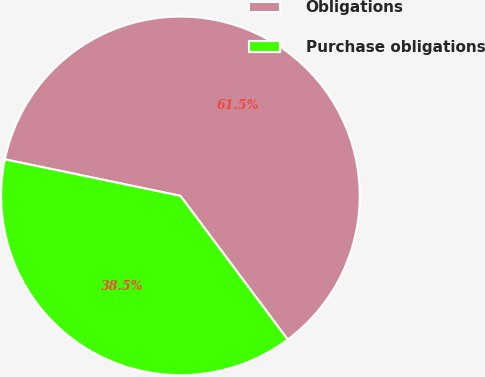Convert chart. <chart><loc_0><loc_0><loc_500><loc_500><pie_chart><fcel>Obligations<fcel>Purchase obligations<nl><fcel>61.53%<fcel>38.47%<nl></chart> 